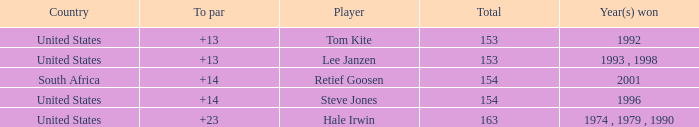What is the total that South Africa had a par greater than 14 None. Parse the full table. {'header': ['Country', 'To par', 'Player', 'Total', 'Year(s) won'], 'rows': [['United States', '+13', 'Tom Kite', '153', '1992'], ['United States', '+13', 'Lee Janzen', '153', '1993 , 1998'], ['South Africa', '+14', 'Retief Goosen', '154', '2001'], ['United States', '+14', 'Steve Jones', '154', '1996'], ['United States', '+23', 'Hale Irwin', '163', '1974 , 1979 , 1990']]} 